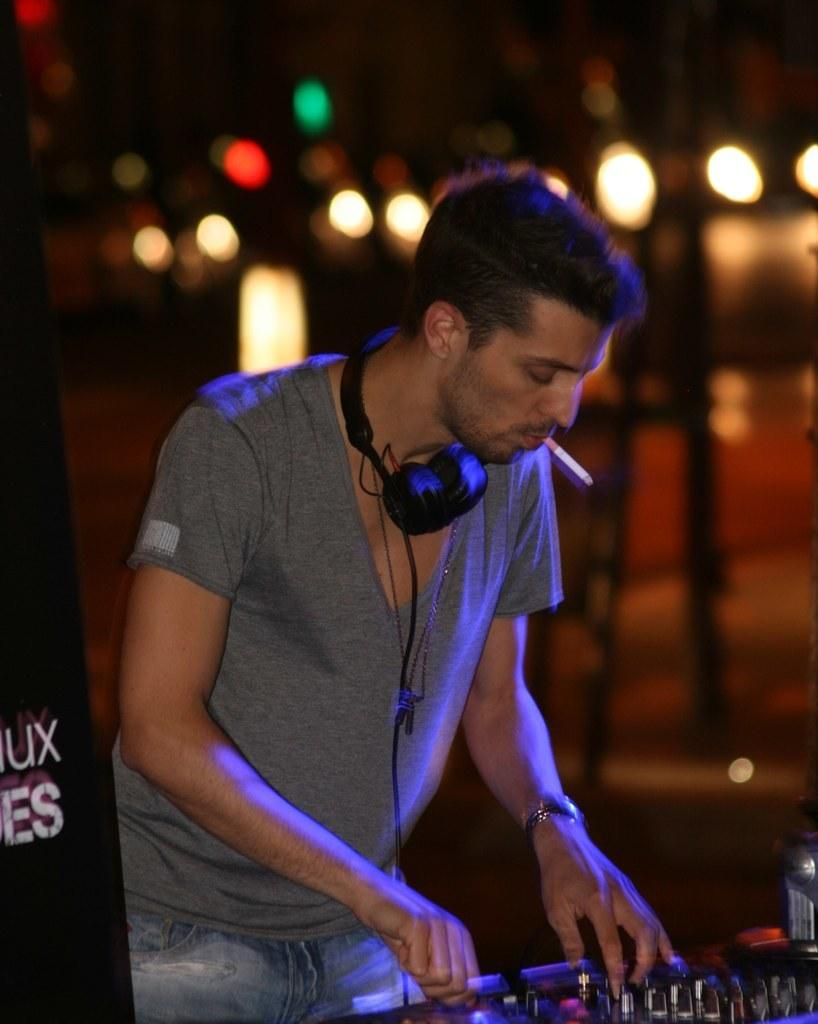What is the main subject of the image? There is a man standing in the image. What equipment is visible in the image? There is a DJ system in the image. What object can be seen in the foreground of the image? There is a board in the image. How would you describe the background of the image? The background of the image is blurred. What type of train can be seen in the image? There is no train present in the image. Can you describe the bee buzzing around the DJ system in the image? There is no bee present in the image; the focus is on the man and the DJ system. 